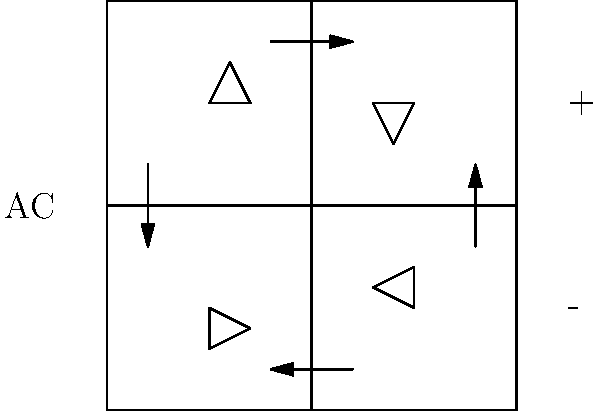In the bridge rectifier circuit shown above, determine the direction of current flow during the positive half-cycle of the AC input. Which diodes conduct, and how does this affect the output polarity? To determine the current flow in a bridge rectifier during the positive half-cycle of AC input, follow these steps:

1. Identify the AC input: In this circuit, the AC input is on the left side.

2. Determine the positive half-cycle: During the positive half-cycle, the left side of the AC input is positive, and the right side is negative.

3. Analyze diode conduction:
   - The top-left diode will conduct because its anode (triangle side) is positive.
   - The bottom-right diode will conduct because its cathode (bar side) is connected to the negative side of the AC input.
   - The other two diodes (top-right and bottom-left) will be reverse-biased and won't conduct.

4. Trace the current path:
   - Current flows from the positive AC input through the top-left diode.
   - It then passes through the load (not shown, but assumed to be connected between + and - on the right side).
   - Finally, it returns to the negative AC input through the bottom-right diode.

5. Determine output polarity:
   - The current flow creates a positive potential at the top of the output and a negative potential at the bottom.
   - This polarity remains the same during both positive and negative half-cycles of the AC input, resulting in full-wave rectification.

6. Visualize the current flow:
   - The arrows in the diagram show the direction of current flow during the positive half-cycle.
Answer: Top-left and bottom-right diodes conduct; current flows clockwise; output: top positive, bottom negative. 